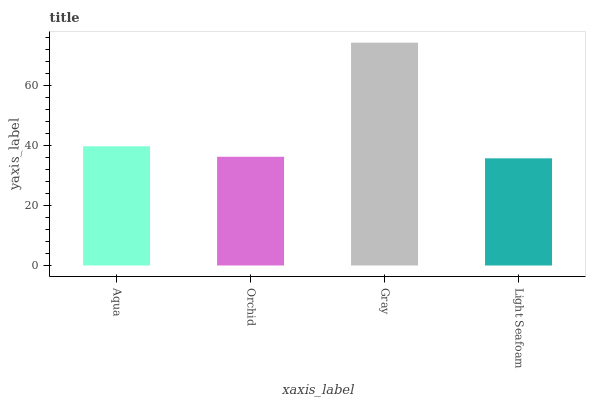Is Light Seafoam the minimum?
Answer yes or no. Yes. Is Gray the maximum?
Answer yes or no. Yes. Is Orchid the minimum?
Answer yes or no. No. Is Orchid the maximum?
Answer yes or no. No. Is Aqua greater than Orchid?
Answer yes or no. Yes. Is Orchid less than Aqua?
Answer yes or no. Yes. Is Orchid greater than Aqua?
Answer yes or no. No. Is Aqua less than Orchid?
Answer yes or no. No. Is Aqua the high median?
Answer yes or no. Yes. Is Orchid the low median?
Answer yes or no. Yes. Is Gray the high median?
Answer yes or no. No. Is Light Seafoam the low median?
Answer yes or no. No. 